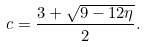<formula> <loc_0><loc_0><loc_500><loc_500>c = \frac { 3 + \sqrt { 9 - 1 2 \eta } } { 2 } .</formula> 